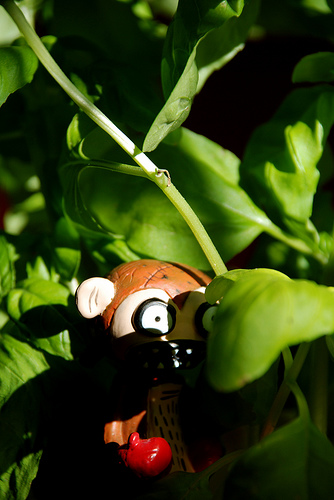<image>
Is there a toy bear in front of the plant? No. The toy bear is not in front of the plant. The spatial positioning shows a different relationship between these objects. 